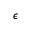<formula> <loc_0><loc_0><loc_500><loc_500>\epsilon</formula> 